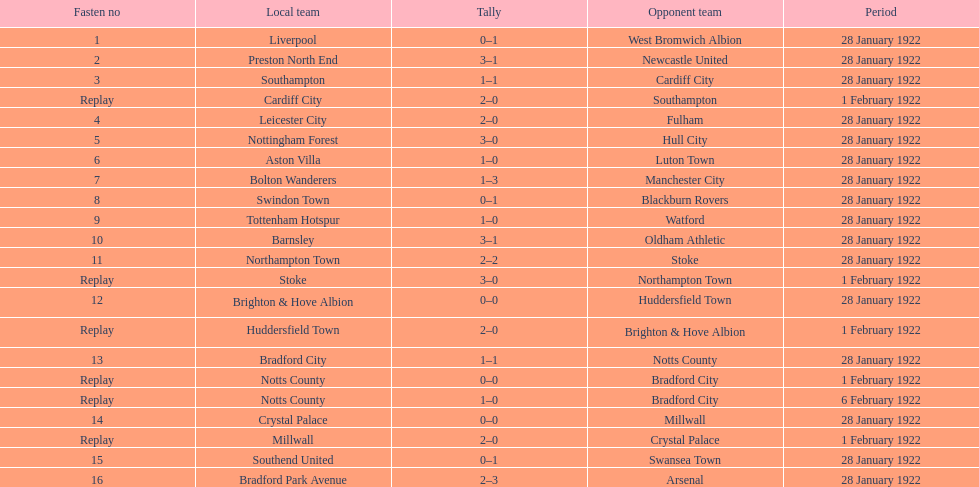Would you mind parsing the complete table? {'header': ['Fasten no', 'Local team', 'Tally', 'Opponent team', 'Period'], 'rows': [['1', 'Liverpool', '0–1', 'West Bromwich Albion', '28 January 1922'], ['2', 'Preston North End', '3–1', 'Newcastle United', '28 January 1922'], ['3', 'Southampton', '1–1', 'Cardiff City', '28 January 1922'], ['Replay', 'Cardiff City', '2–0', 'Southampton', '1 February 1922'], ['4', 'Leicester City', '2–0', 'Fulham', '28 January 1922'], ['5', 'Nottingham Forest', '3–0', 'Hull City', '28 January 1922'], ['6', 'Aston Villa', '1–0', 'Luton Town', '28 January 1922'], ['7', 'Bolton Wanderers', '1–3', 'Manchester City', '28 January 1922'], ['8', 'Swindon Town', '0–1', 'Blackburn Rovers', '28 January 1922'], ['9', 'Tottenham Hotspur', '1–0', 'Watford', '28 January 1922'], ['10', 'Barnsley', '3–1', 'Oldham Athletic', '28 January 1922'], ['11', 'Northampton Town', '2–2', 'Stoke', '28 January 1922'], ['Replay', 'Stoke', '3–0', 'Northampton Town', '1 February 1922'], ['12', 'Brighton & Hove Albion', '0–0', 'Huddersfield Town', '28 January 1922'], ['Replay', 'Huddersfield Town', '2–0', 'Brighton & Hove Albion', '1 February 1922'], ['13', 'Bradford City', '1–1', 'Notts County', '28 January 1922'], ['Replay', 'Notts County', '0–0', 'Bradford City', '1 February 1922'], ['Replay', 'Notts County', '1–0', 'Bradford City', '6 February 1922'], ['14', 'Crystal Palace', '0–0', 'Millwall', '28 January 1922'], ['Replay', 'Millwall', '2–0', 'Crystal Palace', '1 February 1922'], ['15', 'Southend United', '0–1', 'Swansea Town', '28 January 1922'], ['16', 'Bradford Park Avenue', '2–3', 'Arsenal', '28 January 1922']]} What was the total points scored on february 6, 1922? 1. 